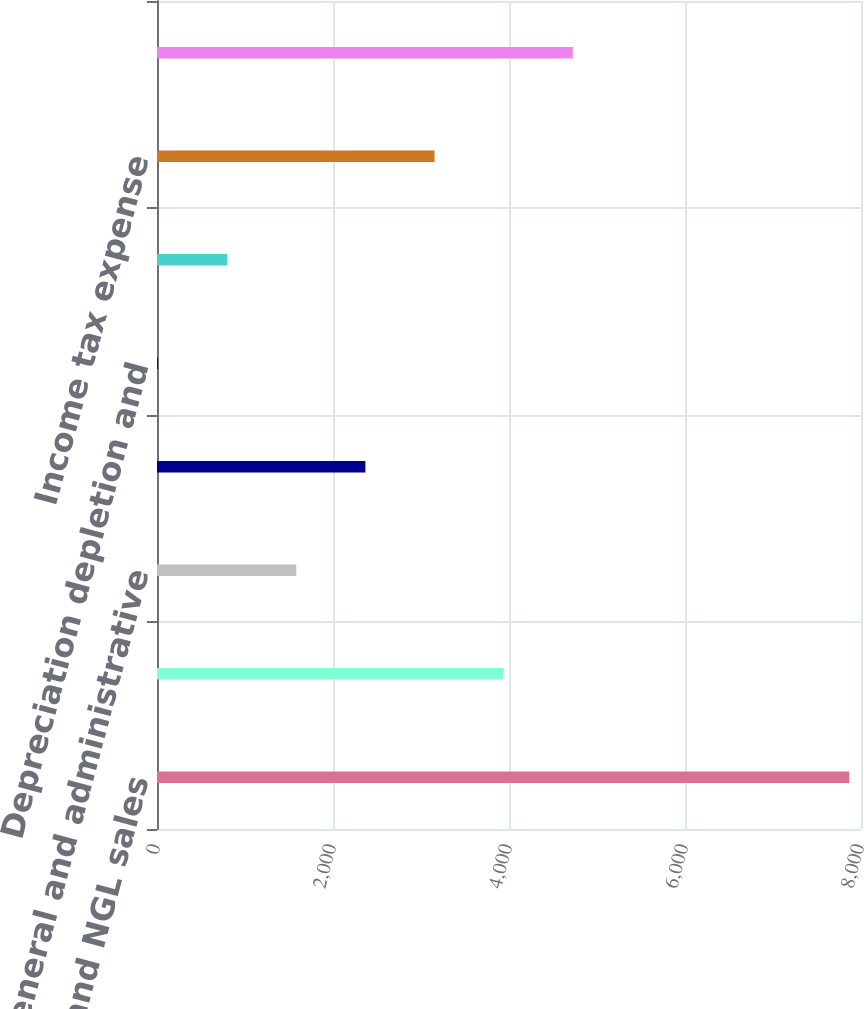<chart> <loc_0><loc_0><loc_500><loc_500><bar_chart><fcel>Oil gas and NGL sales<fcel>Lease operating expenses<fcel>General and administrative<fcel>Production and property taxes<fcel>Depreciation depletion and<fcel>Accretion of asset retirement<fcel>Income tax expense<fcel>Results of operations (1)<nl><fcel>7867<fcel>3939.21<fcel>1582.53<fcel>2368.09<fcel>11.41<fcel>796.97<fcel>3153.65<fcel>4724.77<nl></chart> 